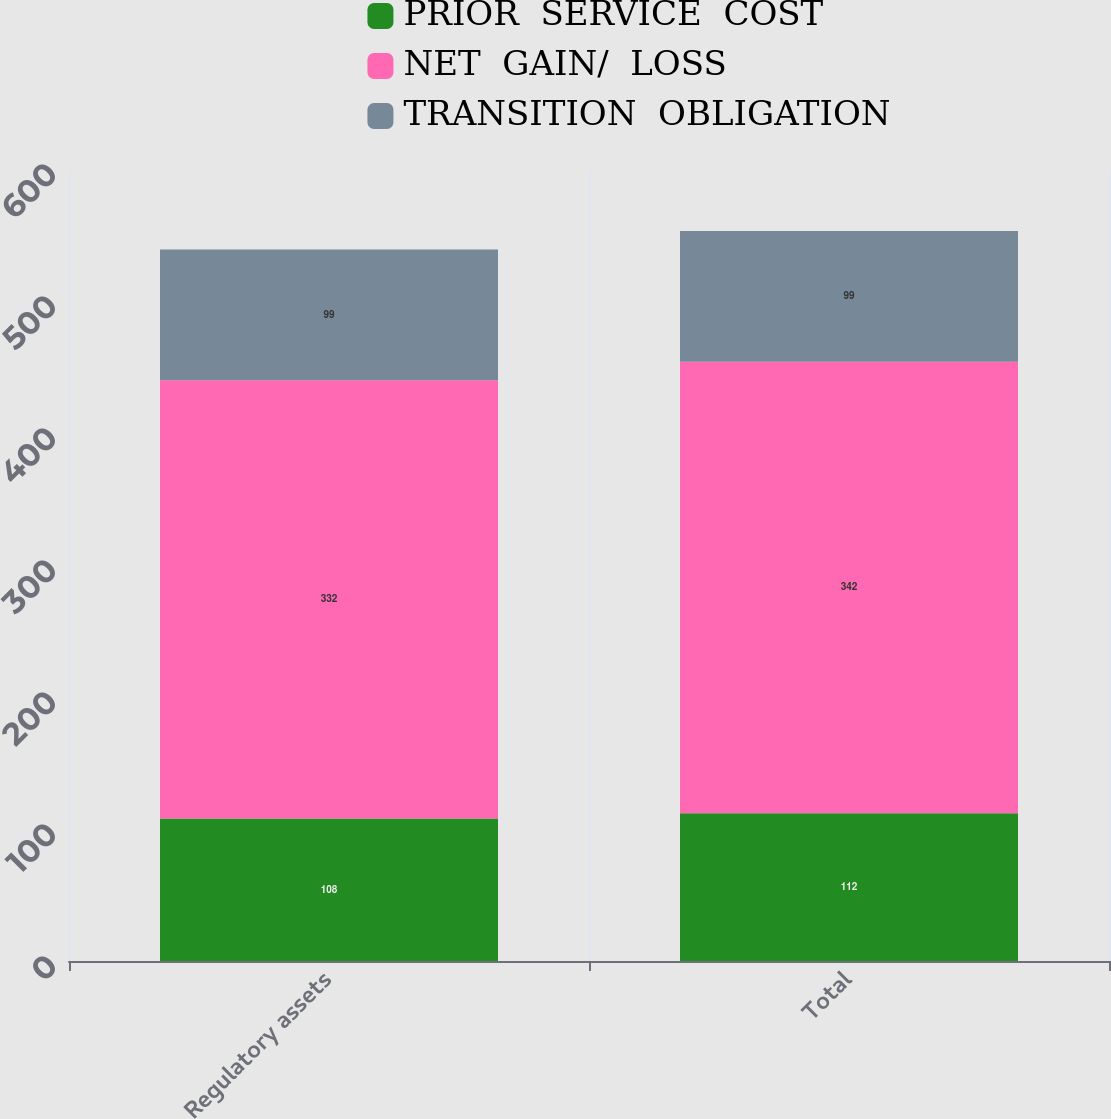<chart> <loc_0><loc_0><loc_500><loc_500><stacked_bar_chart><ecel><fcel>Regulatory assets<fcel>Total<nl><fcel>PRIOR  SERVICE  COST<fcel>108<fcel>112<nl><fcel>NET  GAIN/  LOSS<fcel>332<fcel>342<nl><fcel>TRANSITION  OBLIGATION<fcel>99<fcel>99<nl></chart> 